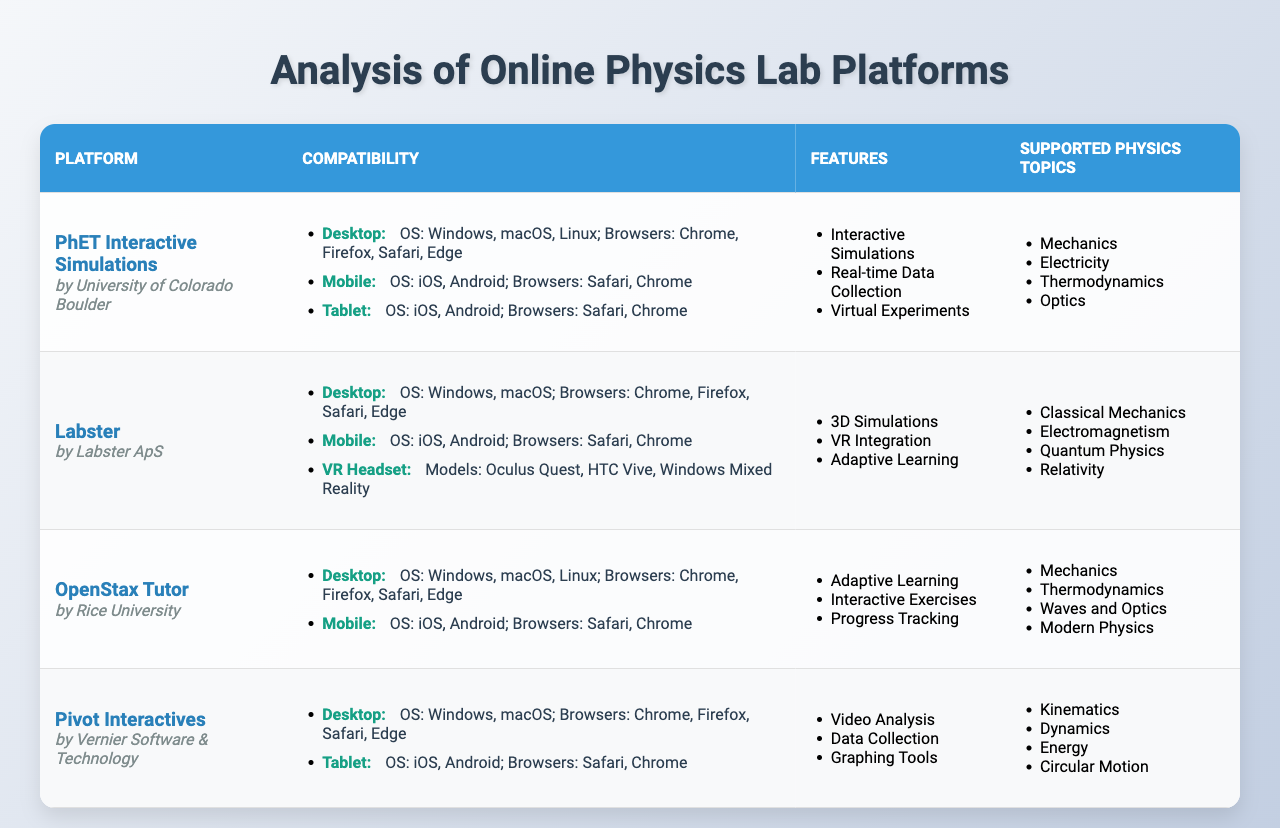What is the name of the platform developed by University of Colorado Boulder? The table lists each platform along with its developer. By looking under the "Developer" column for the platform "PhET Interactive Simulations," it shows "University of Colorado Boulder."
Answer: PhET Interactive Simulations Which platforms are compatible with Windows operating systems? By scanning the "Compatibility" section for each platform, I identify that "PhET Interactive Simulations," "Labster," "OpenStax Tutor," and "Pivot Interactives" all list "Windows" as an operating system requirement.
Answer: 4 platforms Does Labster support VR headsets? The table details the compatibility of each platform. By examining "Labster," I see that it includes compatibility with "VR Headset" and the specific models are listed.
Answer: Yes How many mobile-compatible platforms offer features related to adaptive learning? First, I find all mobile-compatible platforms: "PhET Interactive Simulations," "Labster," and "OpenStax Tutor." Then, I check their features. Only "Labster" and "OpenStax Tutor" mention adaptive learning in their feature lists. In total, there are 2 such platforms.
Answer: 2 platforms What are the supported physics topics of Pivot Interactives? The table includes a column for "Supported Physics Topics" for each platform. I locate "Pivot Interactives" and read the associated list, which includes topics such as "Kinematics," "Dynamics," "Energy," and "Circular Motion."
Answer: Kinematics, Dynamics, Energy, Circular Motion Identify the platforms that offer simulations in electricity. Looking through the "Supported Physics Topics" for each platform, I find that electricity is specifically mentioned only under "Labster," which includes "Electromagnetism," a topic related to electricity.
Answer: Labster Which device types does PhET Interactive Simulations support? I analyze the "Compatibility" section for "PhET Interactive Simulations." It lists compatibility for three device types: Desktop, Mobile, and Tablet.
Answer: Desktop, Mobile, Tablet Which platform has the most supported physics topics and how many are they? Reviewing the "Supported Physics Topics" for each platform, I see that "Labster" supports four topics: "Classical Mechanics," "Electromagnetism," "Quantum Physics," and "Relativity." The other platforms support either three or four topics as well. The count shows that the highest is still four.
Answer: 4 topics Is it true that OpenStax Tutor has features that include video analysis? By scanning the features listed for "OpenStax Tutor" in the table, I can see that it includes "Adaptive Learning," "Interactive Exercises," and "Progress Tracking," but does not include "Video Analysis."
Answer: No What operating systems are compatible with the mobile version of Labster? The "Compatibility" section for "Labster" specifies that its mobile version supports operating systems "iOS" and "Android."
Answer: iOS, Android 